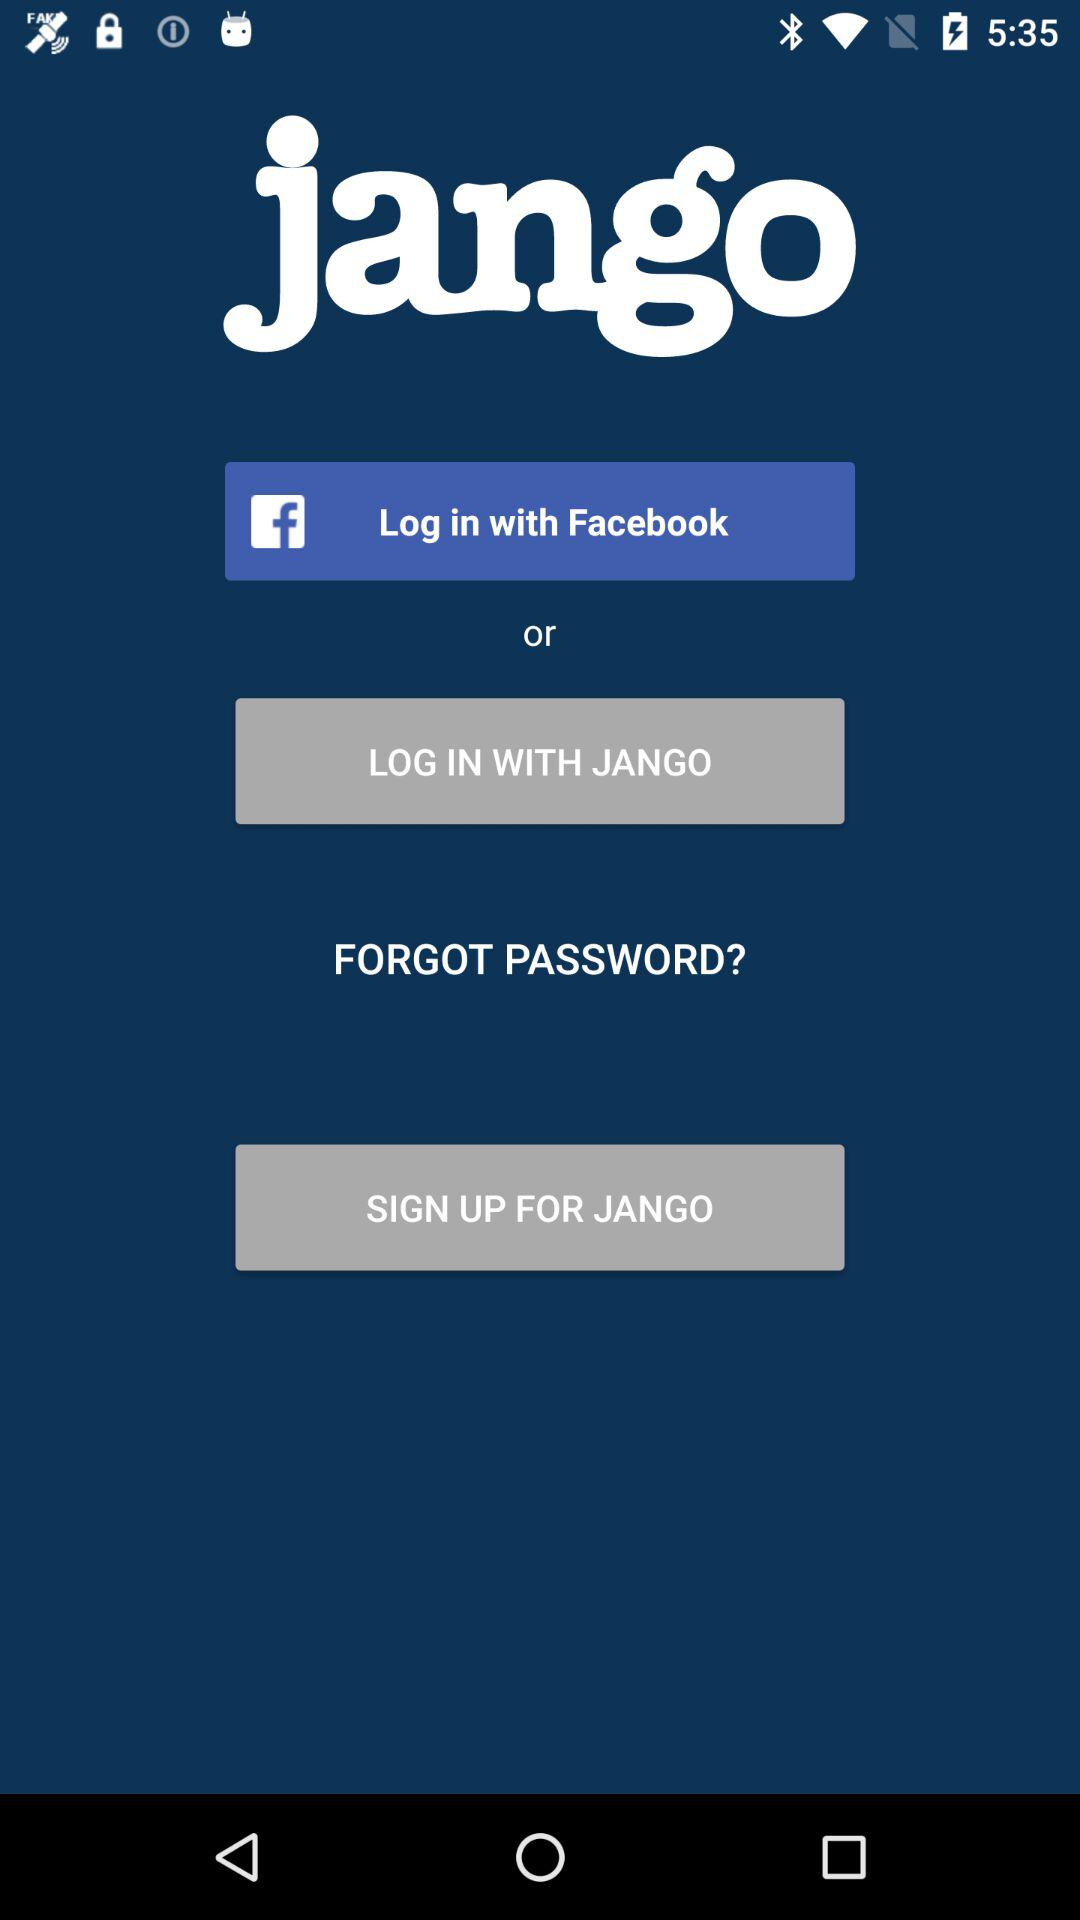What is the application name? The application name is "jango". 